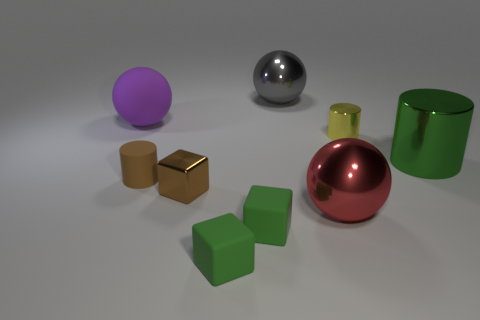Can you describe the different materials that the objects in the image seem to be made of? Certainly! In the image, we can see objects that appear to have diverse textures and finishes. The spheres and the cylinder seem to have a reflective metallic surface, indicating they could be made of metal. The cubes, by contrast, exhibit a matte finish, suggesting they might be composed of plastic or a similar non-metallic material.  Are the objects arranged in any particular pattern or order? The objects are not arranged in a specific pattern; they are instead placed randomly across the surface. This random placement creates an interesting visual composition that does not suggest any particular order or sequence. 